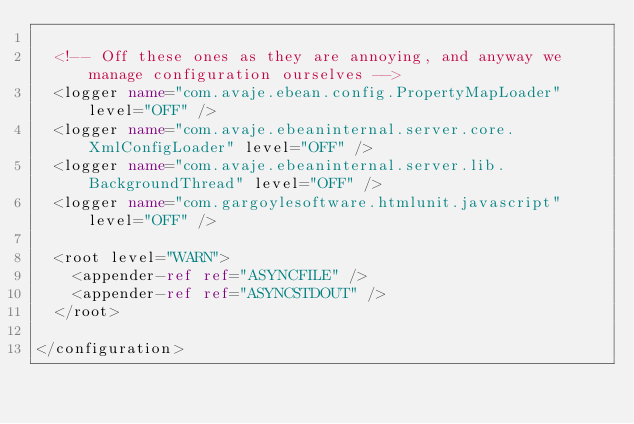Convert code to text. <code><loc_0><loc_0><loc_500><loc_500><_XML_>
  <!-- Off these ones as they are annoying, and anyway we manage configuration ourselves -->
  <logger name="com.avaje.ebean.config.PropertyMapLoader" level="OFF" />
  <logger name="com.avaje.ebeaninternal.server.core.XmlConfigLoader" level="OFF" />
  <logger name="com.avaje.ebeaninternal.server.lib.BackgroundThread" level="OFF" />
  <logger name="com.gargoylesoftware.htmlunit.javascript" level="OFF" />

  <root level="WARN">
    <appender-ref ref="ASYNCFILE" />
    <appender-ref ref="ASYNCSTDOUT" />
  </root>

</configuration>
</code> 